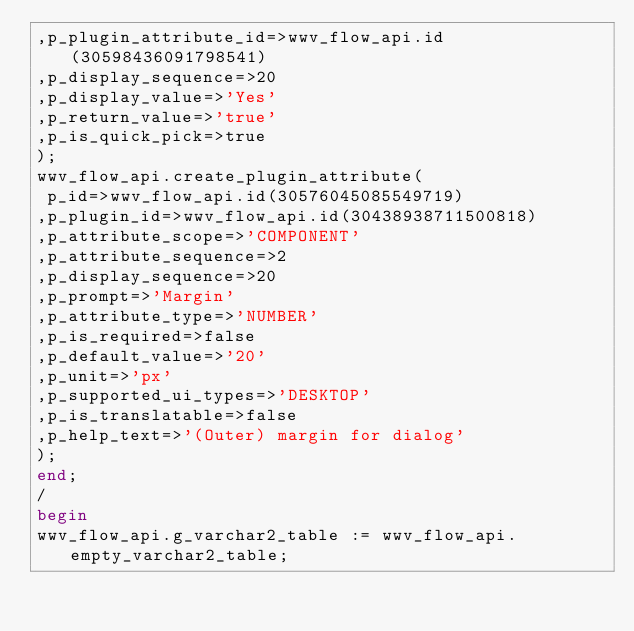Convert code to text. <code><loc_0><loc_0><loc_500><loc_500><_SQL_>,p_plugin_attribute_id=>wwv_flow_api.id(30598436091798541)
,p_display_sequence=>20
,p_display_value=>'Yes'
,p_return_value=>'true'
,p_is_quick_pick=>true
);
wwv_flow_api.create_plugin_attribute(
 p_id=>wwv_flow_api.id(30576045085549719)
,p_plugin_id=>wwv_flow_api.id(30438938711500818)
,p_attribute_scope=>'COMPONENT'
,p_attribute_sequence=>2
,p_display_sequence=>20
,p_prompt=>'Margin'
,p_attribute_type=>'NUMBER'
,p_is_required=>false
,p_default_value=>'20'
,p_unit=>'px'
,p_supported_ui_types=>'DESKTOP'
,p_is_translatable=>false
,p_help_text=>'(Outer) margin for dialog'
);
end;
/
begin
wwv_flow_api.g_varchar2_table := wwv_flow_api.empty_varchar2_table;</code> 